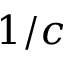<formula> <loc_0><loc_0><loc_500><loc_500>1 / c</formula> 